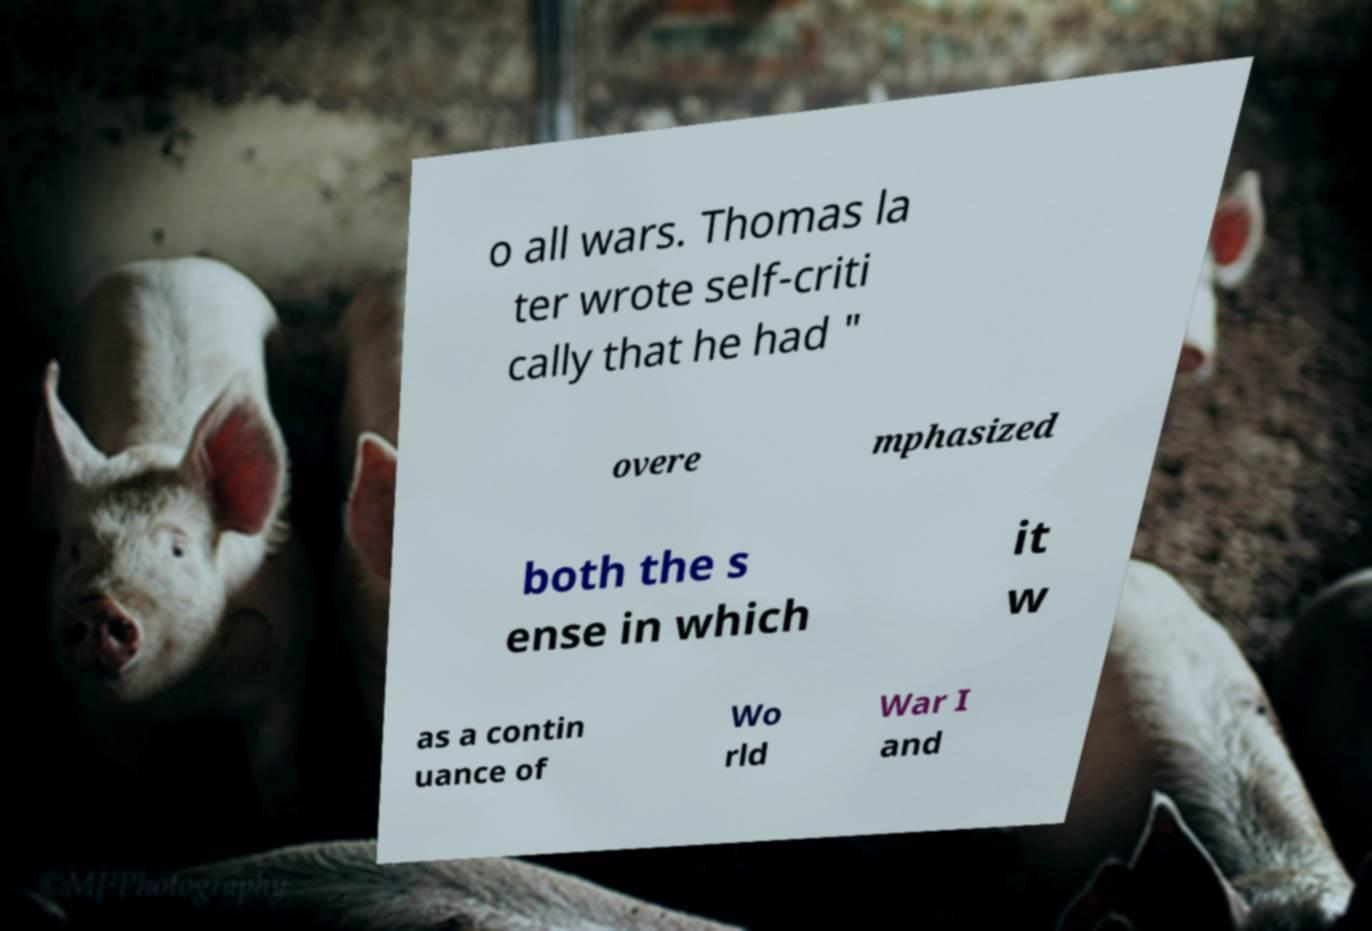I need the written content from this picture converted into text. Can you do that? o all wars. Thomas la ter wrote self-criti cally that he had " overe mphasized both the s ense in which it w as a contin uance of Wo rld War I and 